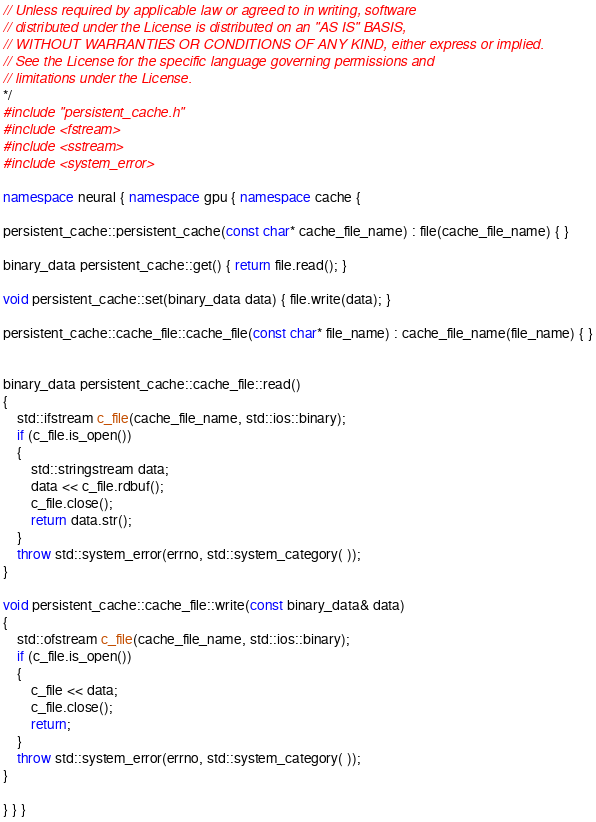Convert code to text. <code><loc_0><loc_0><loc_500><loc_500><_C++_>// Unless required by applicable law or agreed to in writing, software
// distributed under the License is distributed on an "AS IS" BASIS,
// WITHOUT WARRANTIES OR CONDITIONS OF ANY KIND, either express or implied.
// See the License for the specific language governing permissions and
// limitations under the License.
*/
#include "persistent_cache.h"
#include <fstream>
#include <sstream>
#include <system_error>

namespace neural { namespace gpu { namespace cache {

persistent_cache::persistent_cache(const char* cache_file_name) : file(cache_file_name) { }

binary_data persistent_cache::get() { return file.read(); }

void persistent_cache::set(binary_data data) { file.write(data); }

persistent_cache::cache_file::cache_file(const char* file_name) : cache_file_name(file_name) { }


binary_data persistent_cache::cache_file::read()
{
    std::ifstream c_file(cache_file_name, std::ios::binary);
    if (c_file.is_open())
    {
        std::stringstream data;
        data << c_file.rdbuf();
        c_file.close();
        return data.str();
    }
    throw std::system_error(errno, std::system_category( ));
}

void persistent_cache::cache_file::write(const binary_data& data)
{
    std::ofstream c_file(cache_file_name, std::ios::binary);
    if (c_file.is_open())
    {
        c_file << data;
        c_file.close();
        return;
    }
	throw std::system_error(errno, std::system_category( ));
}

} } }</code> 